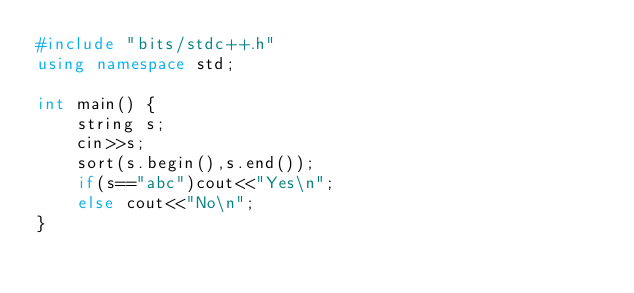Convert code to text. <code><loc_0><loc_0><loc_500><loc_500><_C++_>#include "bits/stdc++.h"
using namespace std;

int main() {
    string s;
    cin>>s;
    sort(s.begin(),s.end());
    if(s=="abc")cout<<"Yes\n";
    else cout<<"No\n";
}</code> 